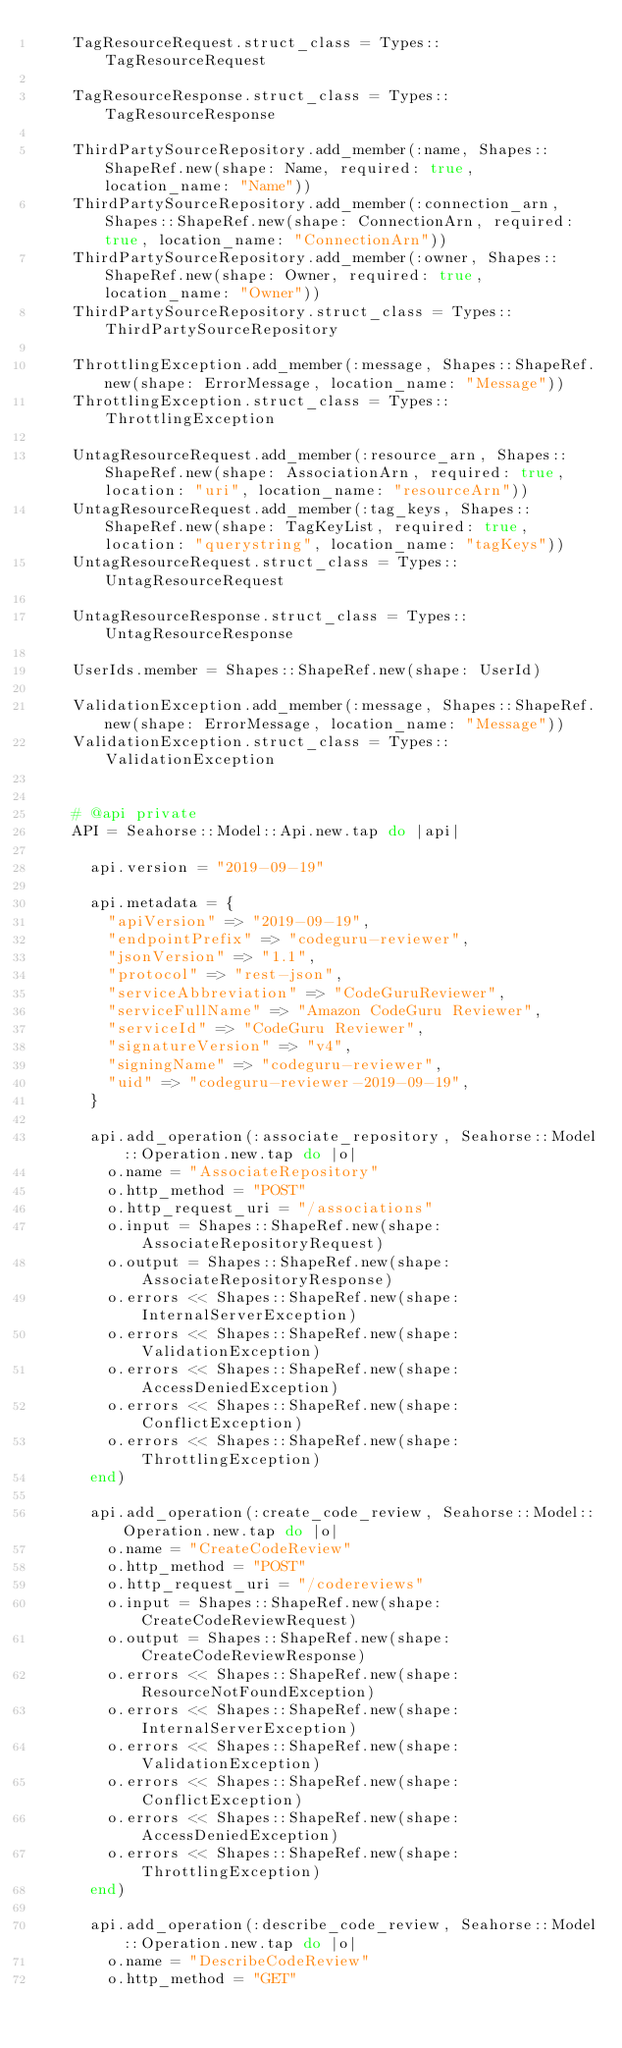<code> <loc_0><loc_0><loc_500><loc_500><_Ruby_>    TagResourceRequest.struct_class = Types::TagResourceRequest

    TagResourceResponse.struct_class = Types::TagResourceResponse

    ThirdPartySourceRepository.add_member(:name, Shapes::ShapeRef.new(shape: Name, required: true, location_name: "Name"))
    ThirdPartySourceRepository.add_member(:connection_arn, Shapes::ShapeRef.new(shape: ConnectionArn, required: true, location_name: "ConnectionArn"))
    ThirdPartySourceRepository.add_member(:owner, Shapes::ShapeRef.new(shape: Owner, required: true, location_name: "Owner"))
    ThirdPartySourceRepository.struct_class = Types::ThirdPartySourceRepository

    ThrottlingException.add_member(:message, Shapes::ShapeRef.new(shape: ErrorMessage, location_name: "Message"))
    ThrottlingException.struct_class = Types::ThrottlingException

    UntagResourceRequest.add_member(:resource_arn, Shapes::ShapeRef.new(shape: AssociationArn, required: true, location: "uri", location_name: "resourceArn"))
    UntagResourceRequest.add_member(:tag_keys, Shapes::ShapeRef.new(shape: TagKeyList, required: true, location: "querystring", location_name: "tagKeys"))
    UntagResourceRequest.struct_class = Types::UntagResourceRequest

    UntagResourceResponse.struct_class = Types::UntagResourceResponse

    UserIds.member = Shapes::ShapeRef.new(shape: UserId)

    ValidationException.add_member(:message, Shapes::ShapeRef.new(shape: ErrorMessage, location_name: "Message"))
    ValidationException.struct_class = Types::ValidationException


    # @api private
    API = Seahorse::Model::Api.new.tap do |api|

      api.version = "2019-09-19"

      api.metadata = {
        "apiVersion" => "2019-09-19",
        "endpointPrefix" => "codeguru-reviewer",
        "jsonVersion" => "1.1",
        "protocol" => "rest-json",
        "serviceAbbreviation" => "CodeGuruReviewer",
        "serviceFullName" => "Amazon CodeGuru Reviewer",
        "serviceId" => "CodeGuru Reviewer",
        "signatureVersion" => "v4",
        "signingName" => "codeguru-reviewer",
        "uid" => "codeguru-reviewer-2019-09-19",
      }

      api.add_operation(:associate_repository, Seahorse::Model::Operation.new.tap do |o|
        o.name = "AssociateRepository"
        o.http_method = "POST"
        o.http_request_uri = "/associations"
        o.input = Shapes::ShapeRef.new(shape: AssociateRepositoryRequest)
        o.output = Shapes::ShapeRef.new(shape: AssociateRepositoryResponse)
        o.errors << Shapes::ShapeRef.new(shape: InternalServerException)
        o.errors << Shapes::ShapeRef.new(shape: ValidationException)
        o.errors << Shapes::ShapeRef.new(shape: AccessDeniedException)
        o.errors << Shapes::ShapeRef.new(shape: ConflictException)
        o.errors << Shapes::ShapeRef.new(shape: ThrottlingException)
      end)

      api.add_operation(:create_code_review, Seahorse::Model::Operation.new.tap do |o|
        o.name = "CreateCodeReview"
        o.http_method = "POST"
        o.http_request_uri = "/codereviews"
        o.input = Shapes::ShapeRef.new(shape: CreateCodeReviewRequest)
        o.output = Shapes::ShapeRef.new(shape: CreateCodeReviewResponse)
        o.errors << Shapes::ShapeRef.new(shape: ResourceNotFoundException)
        o.errors << Shapes::ShapeRef.new(shape: InternalServerException)
        o.errors << Shapes::ShapeRef.new(shape: ValidationException)
        o.errors << Shapes::ShapeRef.new(shape: ConflictException)
        o.errors << Shapes::ShapeRef.new(shape: AccessDeniedException)
        o.errors << Shapes::ShapeRef.new(shape: ThrottlingException)
      end)

      api.add_operation(:describe_code_review, Seahorse::Model::Operation.new.tap do |o|
        o.name = "DescribeCodeReview"
        o.http_method = "GET"</code> 